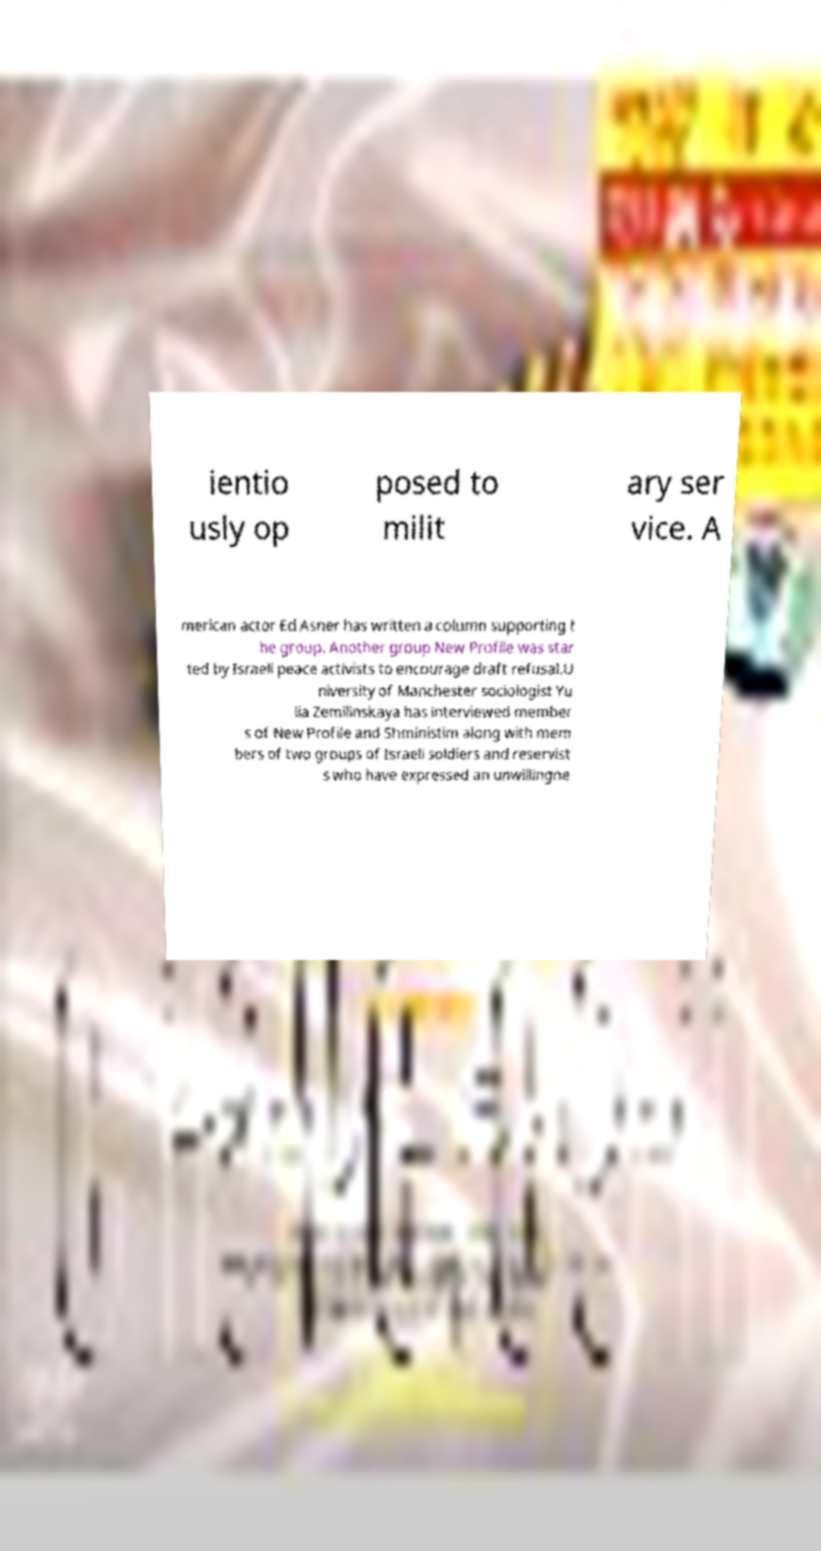What messages or text are displayed in this image? I need them in a readable, typed format. ientio usly op posed to milit ary ser vice. A merican actor Ed Asner has written a column supporting t he group. Another group New Profile was star ted by Israeli peace activists to encourage draft refusal.U niversity of Manchester sociologist Yu lia Zemilinskaya has interviewed member s of New Profile and Shministim along with mem bers of two groups of Israeli soldiers and reservist s who have expressed an unwillingne 